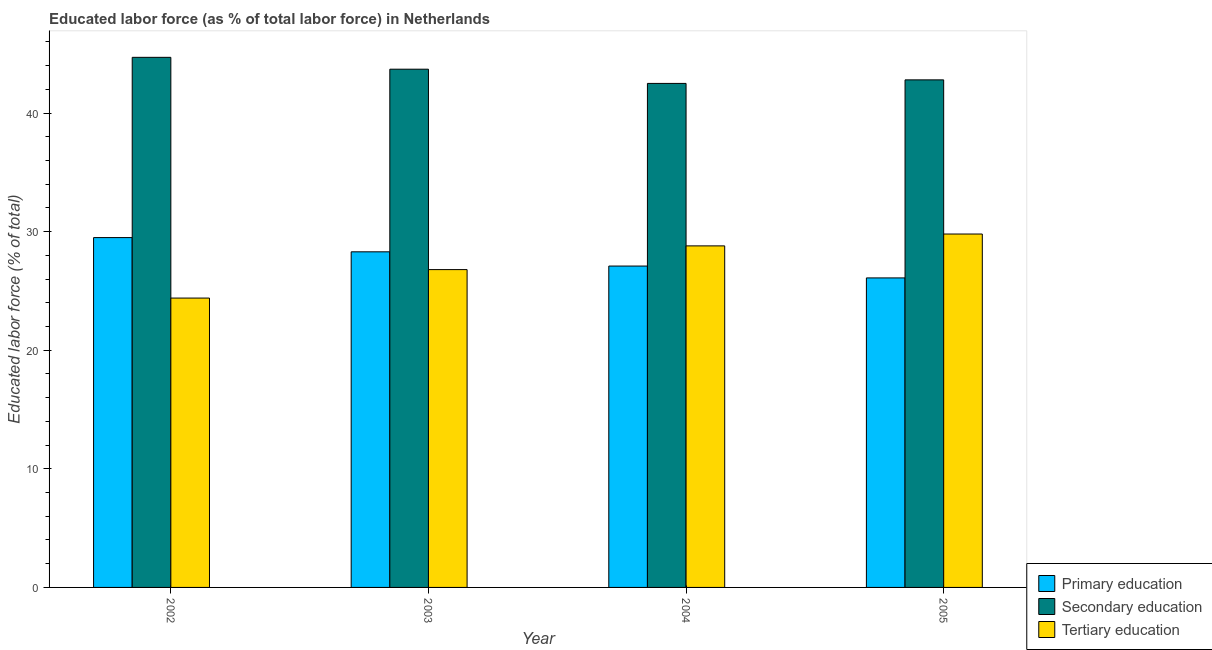How many different coloured bars are there?
Your answer should be compact. 3. Are the number of bars per tick equal to the number of legend labels?
Ensure brevity in your answer.  Yes. Are the number of bars on each tick of the X-axis equal?
Make the answer very short. Yes. How many bars are there on the 3rd tick from the left?
Ensure brevity in your answer.  3. What is the label of the 1st group of bars from the left?
Provide a short and direct response. 2002. What is the percentage of labor force who received tertiary education in 2004?
Your answer should be very brief. 28.8. Across all years, what is the maximum percentage of labor force who received primary education?
Your answer should be very brief. 29.5. Across all years, what is the minimum percentage of labor force who received tertiary education?
Ensure brevity in your answer.  24.4. In which year was the percentage of labor force who received tertiary education maximum?
Offer a terse response. 2005. What is the total percentage of labor force who received primary education in the graph?
Offer a terse response. 111. What is the difference between the percentage of labor force who received secondary education in 2002 and that in 2005?
Offer a very short reply. 1.9. What is the difference between the percentage of labor force who received primary education in 2003 and the percentage of labor force who received tertiary education in 2004?
Provide a succinct answer. 1.2. What is the average percentage of labor force who received tertiary education per year?
Give a very brief answer. 27.45. What is the ratio of the percentage of labor force who received tertiary education in 2003 to that in 2004?
Offer a terse response. 0.93. Is the percentage of labor force who received secondary education in 2002 less than that in 2004?
Your response must be concise. No. What is the difference between the highest and the lowest percentage of labor force who received secondary education?
Ensure brevity in your answer.  2.2. In how many years, is the percentage of labor force who received secondary education greater than the average percentage of labor force who received secondary education taken over all years?
Ensure brevity in your answer.  2. Is the sum of the percentage of labor force who received secondary education in 2002 and 2004 greater than the maximum percentage of labor force who received tertiary education across all years?
Ensure brevity in your answer.  Yes. What does the 3rd bar from the left in 2002 represents?
Provide a short and direct response. Tertiary education. What does the 3rd bar from the right in 2004 represents?
Offer a very short reply. Primary education. How many bars are there?
Your answer should be very brief. 12. Are all the bars in the graph horizontal?
Make the answer very short. No. How many years are there in the graph?
Ensure brevity in your answer.  4. Does the graph contain any zero values?
Offer a terse response. No. Where does the legend appear in the graph?
Your answer should be compact. Bottom right. How many legend labels are there?
Provide a short and direct response. 3. How are the legend labels stacked?
Offer a terse response. Vertical. What is the title of the graph?
Ensure brevity in your answer.  Educated labor force (as % of total labor force) in Netherlands. What is the label or title of the Y-axis?
Your answer should be compact. Educated labor force (% of total). What is the Educated labor force (% of total) in Primary education in 2002?
Provide a short and direct response. 29.5. What is the Educated labor force (% of total) of Secondary education in 2002?
Keep it short and to the point. 44.7. What is the Educated labor force (% of total) in Tertiary education in 2002?
Your answer should be very brief. 24.4. What is the Educated labor force (% of total) in Primary education in 2003?
Offer a very short reply. 28.3. What is the Educated labor force (% of total) of Secondary education in 2003?
Your answer should be very brief. 43.7. What is the Educated labor force (% of total) of Tertiary education in 2003?
Your response must be concise. 26.8. What is the Educated labor force (% of total) in Primary education in 2004?
Offer a terse response. 27.1. What is the Educated labor force (% of total) of Secondary education in 2004?
Provide a short and direct response. 42.5. What is the Educated labor force (% of total) in Tertiary education in 2004?
Ensure brevity in your answer.  28.8. What is the Educated labor force (% of total) in Primary education in 2005?
Your answer should be compact. 26.1. What is the Educated labor force (% of total) in Secondary education in 2005?
Your answer should be very brief. 42.8. What is the Educated labor force (% of total) in Tertiary education in 2005?
Your answer should be very brief. 29.8. Across all years, what is the maximum Educated labor force (% of total) in Primary education?
Provide a short and direct response. 29.5. Across all years, what is the maximum Educated labor force (% of total) in Secondary education?
Your response must be concise. 44.7. Across all years, what is the maximum Educated labor force (% of total) of Tertiary education?
Your response must be concise. 29.8. Across all years, what is the minimum Educated labor force (% of total) of Primary education?
Offer a very short reply. 26.1. Across all years, what is the minimum Educated labor force (% of total) of Secondary education?
Give a very brief answer. 42.5. Across all years, what is the minimum Educated labor force (% of total) of Tertiary education?
Offer a very short reply. 24.4. What is the total Educated labor force (% of total) of Primary education in the graph?
Offer a very short reply. 111. What is the total Educated labor force (% of total) in Secondary education in the graph?
Your response must be concise. 173.7. What is the total Educated labor force (% of total) in Tertiary education in the graph?
Your answer should be very brief. 109.8. What is the difference between the Educated labor force (% of total) in Primary education in 2002 and that in 2003?
Make the answer very short. 1.2. What is the difference between the Educated labor force (% of total) in Tertiary education in 2002 and that in 2003?
Make the answer very short. -2.4. What is the difference between the Educated labor force (% of total) in Primary education in 2002 and that in 2004?
Offer a terse response. 2.4. What is the difference between the Educated labor force (% of total) of Secondary education in 2002 and that in 2004?
Your answer should be very brief. 2.2. What is the difference between the Educated labor force (% of total) in Tertiary education in 2002 and that in 2004?
Your response must be concise. -4.4. What is the difference between the Educated labor force (% of total) of Tertiary education in 2002 and that in 2005?
Your answer should be compact. -5.4. What is the difference between the Educated labor force (% of total) of Primary education in 2003 and that in 2004?
Your response must be concise. 1.2. What is the difference between the Educated labor force (% of total) of Primary education in 2003 and that in 2005?
Offer a terse response. 2.2. What is the difference between the Educated labor force (% of total) in Secondary education in 2003 and that in 2005?
Keep it short and to the point. 0.9. What is the difference between the Educated labor force (% of total) in Primary education in 2002 and the Educated labor force (% of total) in Secondary education in 2003?
Offer a very short reply. -14.2. What is the difference between the Educated labor force (% of total) of Primary education in 2002 and the Educated labor force (% of total) of Tertiary education in 2003?
Your answer should be very brief. 2.7. What is the difference between the Educated labor force (% of total) in Primary education in 2002 and the Educated labor force (% of total) in Tertiary education in 2004?
Your answer should be compact. 0.7. What is the difference between the Educated labor force (% of total) of Primary education in 2003 and the Educated labor force (% of total) of Secondary education in 2004?
Keep it short and to the point. -14.2. What is the difference between the Educated labor force (% of total) of Primary education in 2003 and the Educated labor force (% of total) of Tertiary education in 2004?
Provide a short and direct response. -0.5. What is the difference between the Educated labor force (% of total) in Secondary education in 2003 and the Educated labor force (% of total) in Tertiary education in 2004?
Offer a terse response. 14.9. What is the difference between the Educated labor force (% of total) in Primary education in 2003 and the Educated labor force (% of total) in Secondary education in 2005?
Your answer should be compact. -14.5. What is the difference between the Educated labor force (% of total) in Secondary education in 2003 and the Educated labor force (% of total) in Tertiary education in 2005?
Keep it short and to the point. 13.9. What is the difference between the Educated labor force (% of total) of Primary education in 2004 and the Educated labor force (% of total) of Secondary education in 2005?
Make the answer very short. -15.7. What is the difference between the Educated labor force (% of total) of Primary education in 2004 and the Educated labor force (% of total) of Tertiary education in 2005?
Offer a very short reply. -2.7. What is the average Educated labor force (% of total) in Primary education per year?
Your answer should be very brief. 27.75. What is the average Educated labor force (% of total) in Secondary education per year?
Offer a very short reply. 43.42. What is the average Educated labor force (% of total) in Tertiary education per year?
Offer a terse response. 27.45. In the year 2002, what is the difference between the Educated labor force (% of total) of Primary education and Educated labor force (% of total) of Secondary education?
Your response must be concise. -15.2. In the year 2002, what is the difference between the Educated labor force (% of total) in Secondary education and Educated labor force (% of total) in Tertiary education?
Provide a succinct answer. 20.3. In the year 2003, what is the difference between the Educated labor force (% of total) of Primary education and Educated labor force (% of total) of Secondary education?
Offer a terse response. -15.4. In the year 2003, what is the difference between the Educated labor force (% of total) in Primary education and Educated labor force (% of total) in Tertiary education?
Your answer should be compact. 1.5. In the year 2004, what is the difference between the Educated labor force (% of total) of Primary education and Educated labor force (% of total) of Secondary education?
Provide a succinct answer. -15.4. In the year 2005, what is the difference between the Educated labor force (% of total) in Primary education and Educated labor force (% of total) in Secondary education?
Make the answer very short. -16.7. In the year 2005, what is the difference between the Educated labor force (% of total) of Primary education and Educated labor force (% of total) of Tertiary education?
Provide a short and direct response. -3.7. What is the ratio of the Educated labor force (% of total) in Primary education in 2002 to that in 2003?
Keep it short and to the point. 1.04. What is the ratio of the Educated labor force (% of total) of Secondary education in 2002 to that in 2003?
Your response must be concise. 1.02. What is the ratio of the Educated labor force (% of total) in Tertiary education in 2002 to that in 2003?
Your answer should be very brief. 0.91. What is the ratio of the Educated labor force (% of total) of Primary education in 2002 to that in 2004?
Give a very brief answer. 1.09. What is the ratio of the Educated labor force (% of total) of Secondary education in 2002 to that in 2004?
Ensure brevity in your answer.  1.05. What is the ratio of the Educated labor force (% of total) in Tertiary education in 2002 to that in 2004?
Make the answer very short. 0.85. What is the ratio of the Educated labor force (% of total) in Primary education in 2002 to that in 2005?
Offer a terse response. 1.13. What is the ratio of the Educated labor force (% of total) of Secondary education in 2002 to that in 2005?
Provide a succinct answer. 1.04. What is the ratio of the Educated labor force (% of total) of Tertiary education in 2002 to that in 2005?
Provide a succinct answer. 0.82. What is the ratio of the Educated labor force (% of total) in Primary education in 2003 to that in 2004?
Provide a succinct answer. 1.04. What is the ratio of the Educated labor force (% of total) in Secondary education in 2003 to that in 2004?
Offer a terse response. 1.03. What is the ratio of the Educated labor force (% of total) in Tertiary education in 2003 to that in 2004?
Offer a terse response. 0.93. What is the ratio of the Educated labor force (% of total) of Primary education in 2003 to that in 2005?
Give a very brief answer. 1.08. What is the ratio of the Educated labor force (% of total) of Secondary education in 2003 to that in 2005?
Provide a short and direct response. 1.02. What is the ratio of the Educated labor force (% of total) in Tertiary education in 2003 to that in 2005?
Your answer should be compact. 0.9. What is the ratio of the Educated labor force (% of total) of Primary education in 2004 to that in 2005?
Provide a short and direct response. 1.04. What is the ratio of the Educated labor force (% of total) in Tertiary education in 2004 to that in 2005?
Ensure brevity in your answer.  0.97. What is the difference between the highest and the second highest Educated labor force (% of total) in Primary education?
Your answer should be compact. 1.2. 